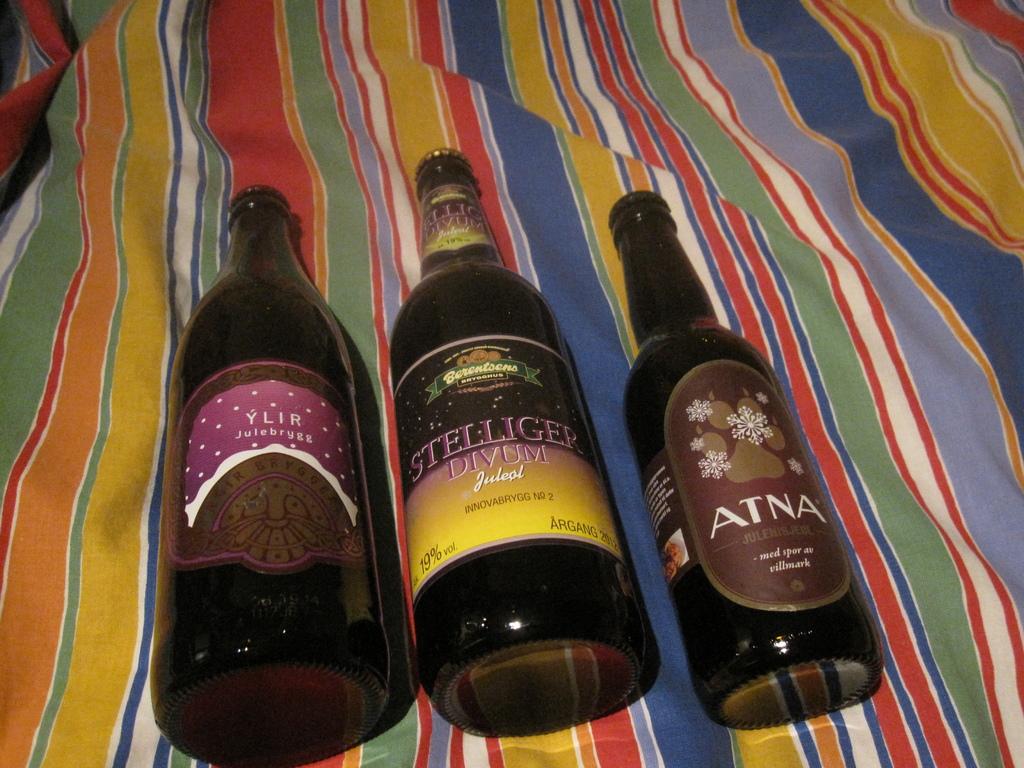What's the alcohol content in the middle bottle?
Give a very brief answer. 19%. What is the brand on the bottle on the right hand side?
Offer a terse response. Atna. 